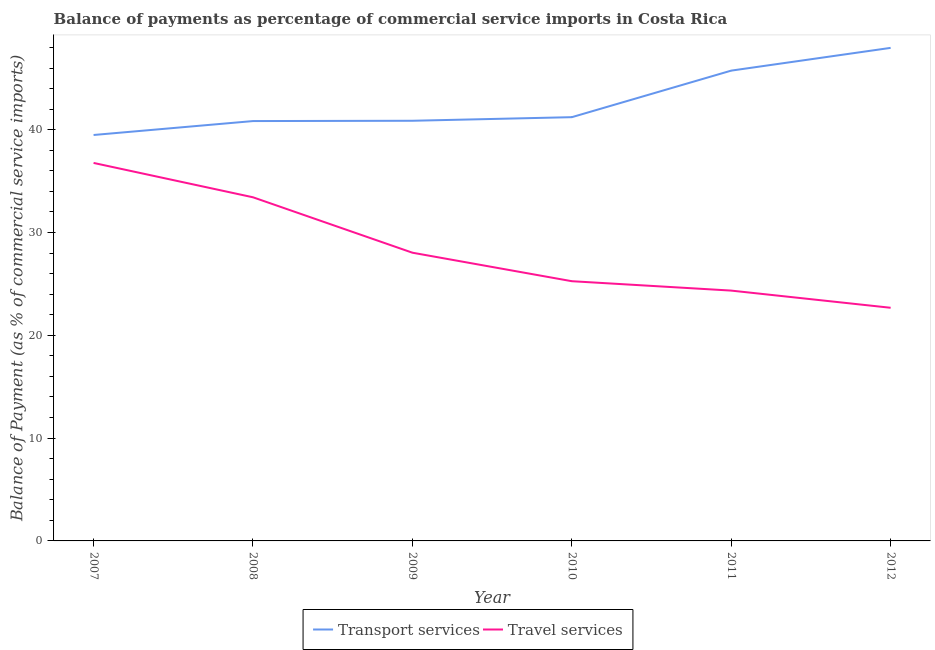How many different coloured lines are there?
Provide a short and direct response. 2. What is the balance of payments of travel services in 2010?
Offer a very short reply. 25.26. Across all years, what is the maximum balance of payments of travel services?
Provide a succinct answer. 36.77. Across all years, what is the minimum balance of payments of transport services?
Your response must be concise. 39.48. In which year was the balance of payments of travel services maximum?
Offer a terse response. 2007. What is the total balance of payments of travel services in the graph?
Your answer should be compact. 170.52. What is the difference between the balance of payments of travel services in 2011 and that in 2012?
Your response must be concise. 1.67. What is the difference between the balance of payments of travel services in 2010 and the balance of payments of transport services in 2007?
Keep it short and to the point. -14.22. What is the average balance of payments of travel services per year?
Your answer should be very brief. 28.42. In the year 2008, what is the difference between the balance of payments of transport services and balance of payments of travel services?
Offer a very short reply. 7.41. In how many years, is the balance of payments of transport services greater than 16 %?
Your answer should be very brief. 6. What is the ratio of the balance of payments of travel services in 2010 to that in 2011?
Your response must be concise. 1.04. Is the balance of payments of transport services in 2008 less than that in 2010?
Your response must be concise. Yes. What is the difference between the highest and the second highest balance of payments of transport services?
Make the answer very short. 2.21. What is the difference between the highest and the lowest balance of payments of travel services?
Offer a terse response. 14.09. Does the balance of payments of travel services monotonically increase over the years?
Ensure brevity in your answer.  No. Is the balance of payments of travel services strictly greater than the balance of payments of transport services over the years?
Provide a succinct answer. No. Is the balance of payments of transport services strictly less than the balance of payments of travel services over the years?
Ensure brevity in your answer.  No. Are the values on the major ticks of Y-axis written in scientific E-notation?
Ensure brevity in your answer.  No. Does the graph contain any zero values?
Your answer should be very brief. No. Where does the legend appear in the graph?
Provide a succinct answer. Bottom center. How are the legend labels stacked?
Make the answer very short. Horizontal. What is the title of the graph?
Make the answer very short. Balance of payments as percentage of commercial service imports in Costa Rica. What is the label or title of the X-axis?
Ensure brevity in your answer.  Year. What is the label or title of the Y-axis?
Provide a short and direct response. Balance of Payment (as % of commercial service imports). What is the Balance of Payment (as % of commercial service imports) of Transport services in 2007?
Keep it short and to the point. 39.48. What is the Balance of Payment (as % of commercial service imports) of Travel services in 2007?
Provide a short and direct response. 36.77. What is the Balance of Payment (as % of commercial service imports) in Transport services in 2008?
Provide a short and direct response. 40.84. What is the Balance of Payment (as % of commercial service imports) in Travel services in 2008?
Your response must be concise. 33.43. What is the Balance of Payment (as % of commercial service imports) of Transport services in 2009?
Your response must be concise. 40.87. What is the Balance of Payment (as % of commercial service imports) of Travel services in 2009?
Your answer should be compact. 28.03. What is the Balance of Payment (as % of commercial service imports) of Transport services in 2010?
Give a very brief answer. 41.22. What is the Balance of Payment (as % of commercial service imports) of Travel services in 2010?
Ensure brevity in your answer.  25.26. What is the Balance of Payment (as % of commercial service imports) in Transport services in 2011?
Make the answer very short. 45.75. What is the Balance of Payment (as % of commercial service imports) of Travel services in 2011?
Provide a succinct answer. 24.35. What is the Balance of Payment (as % of commercial service imports) of Transport services in 2012?
Make the answer very short. 47.96. What is the Balance of Payment (as % of commercial service imports) of Travel services in 2012?
Offer a terse response. 22.68. Across all years, what is the maximum Balance of Payment (as % of commercial service imports) of Transport services?
Provide a succinct answer. 47.96. Across all years, what is the maximum Balance of Payment (as % of commercial service imports) in Travel services?
Give a very brief answer. 36.77. Across all years, what is the minimum Balance of Payment (as % of commercial service imports) of Transport services?
Make the answer very short. 39.48. Across all years, what is the minimum Balance of Payment (as % of commercial service imports) of Travel services?
Provide a succinct answer. 22.68. What is the total Balance of Payment (as % of commercial service imports) in Transport services in the graph?
Make the answer very short. 256.11. What is the total Balance of Payment (as % of commercial service imports) in Travel services in the graph?
Keep it short and to the point. 170.52. What is the difference between the Balance of Payment (as % of commercial service imports) of Transport services in 2007 and that in 2008?
Offer a terse response. -1.35. What is the difference between the Balance of Payment (as % of commercial service imports) of Travel services in 2007 and that in 2008?
Provide a short and direct response. 3.34. What is the difference between the Balance of Payment (as % of commercial service imports) in Transport services in 2007 and that in 2009?
Ensure brevity in your answer.  -1.38. What is the difference between the Balance of Payment (as % of commercial service imports) in Travel services in 2007 and that in 2009?
Your response must be concise. 8.73. What is the difference between the Balance of Payment (as % of commercial service imports) of Transport services in 2007 and that in 2010?
Ensure brevity in your answer.  -1.73. What is the difference between the Balance of Payment (as % of commercial service imports) of Travel services in 2007 and that in 2010?
Make the answer very short. 11.5. What is the difference between the Balance of Payment (as % of commercial service imports) in Transport services in 2007 and that in 2011?
Make the answer very short. -6.26. What is the difference between the Balance of Payment (as % of commercial service imports) in Travel services in 2007 and that in 2011?
Ensure brevity in your answer.  12.42. What is the difference between the Balance of Payment (as % of commercial service imports) in Transport services in 2007 and that in 2012?
Your response must be concise. -8.47. What is the difference between the Balance of Payment (as % of commercial service imports) of Travel services in 2007 and that in 2012?
Offer a terse response. 14.09. What is the difference between the Balance of Payment (as % of commercial service imports) in Transport services in 2008 and that in 2009?
Your response must be concise. -0.03. What is the difference between the Balance of Payment (as % of commercial service imports) in Travel services in 2008 and that in 2009?
Ensure brevity in your answer.  5.39. What is the difference between the Balance of Payment (as % of commercial service imports) of Transport services in 2008 and that in 2010?
Provide a short and direct response. -0.38. What is the difference between the Balance of Payment (as % of commercial service imports) in Travel services in 2008 and that in 2010?
Your answer should be very brief. 8.16. What is the difference between the Balance of Payment (as % of commercial service imports) of Transport services in 2008 and that in 2011?
Your response must be concise. -4.91. What is the difference between the Balance of Payment (as % of commercial service imports) in Travel services in 2008 and that in 2011?
Provide a short and direct response. 9.08. What is the difference between the Balance of Payment (as % of commercial service imports) in Transport services in 2008 and that in 2012?
Keep it short and to the point. -7.12. What is the difference between the Balance of Payment (as % of commercial service imports) of Travel services in 2008 and that in 2012?
Ensure brevity in your answer.  10.75. What is the difference between the Balance of Payment (as % of commercial service imports) of Transport services in 2009 and that in 2010?
Your response must be concise. -0.35. What is the difference between the Balance of Payment (as % of commercial service imports) of Travel services in 2009 and that in 2010?
Provide a succinct answer. 2.77. What is the difference between the Balance of Payment (as % of commercial service imports) of Transport services in 2009 and that in 2011?
Your answer should be compact. -4.88. What is the difference between the Balance of Payment (as % of commercial service imports) of Travel services in 2009 and that in 2011?
Your answer should be compact. 3.69. What is the difference between the Balance of Payment (as % of commercial service imports) of Transport services in 2009 and that in 2012?
Your answer should be very brief. -7.09. What is the difference between the Balance of Payment (as % of commercial service imports) in Travel services in 2009 and that in 2012?
Give a very brief answer. 5.36. What is the difference between the Balance of Payment (as % of commercial service imports) in Transport services in 2010 and that in 2011?
Make the answer very short. -4.53. What is the difference between the Balance of Payment (as % of commercial service imports) of Travel services in 2010 and that in 2011?
Your answer should be very brief. 0.91. What is the difference between the Balance of Payment (as % of commercial service imports) in Transport services in 2010 and that in 2012?
Your response must be concise. -6.74. What is the difference between the Balance of Payment (as % of commercial service imports) in Travel services in 2010 and that in 2012?
Provide a short and direct response. 2.58. What is the difference between the Balance of Payment (as % of commercial service imports) of Transport services in 2011 and that in 2012?
Your response must be concise. -2.21. What is the difference between the Balance of Payment (as % of commercial service imports) of Travel services in 2011 and that in 2012?
Provide a short and direct response. 1.67. What is the difference between the Balance of Payment (as % of commercial service imports) of Transport services in 2007 and the Balance of Payment (as % of commercial service imports) of Travel services in 2008?
Offer a very short reply. 6.06. What is the difference between the Balance of Payment (as % of commercial service imports) of Transport services in 2007 and the Balance of Payment (as % of commercial service imports) of Travel services in 2009?
Provide a succinct answer. 11.45. What is the difference between the Balance of Payment (as % of commercial service imports) in Transport services in 2007 and the Balance of Payment (as % of commercial service imports) in Travel services in 2010?
Your response must be concise. 14.22. What is the difference between the Balance of Payment (as % of commercial service imports) of Transport services in 2007 and the Balance of Payment (as % of commercial service imports) of Travel services in 2011?
Offer a terse response. 15.14. What is the difference between the Balance of Payment (as % of commercial service imports) in Transport services in 2007 and the Balance of Payment (as % of commercial service imports) in Travel services in 2012?
Keep it short and to the point. 16.81. What is the difference between the Balance of Payment (as % of commercial service imports) of Transport services in 2008 and the Balance of Payment (as % of commercial service imports) of Travel services in 2009?
Your answer should be very brief. 12.8. What is the difference between the Balance of Payment (as % of commercial service imports) of Transport services in 2008 and the Balance of Payment (as % of commercial service imports) of Travel services in 2010?
Make the answer very short. 15.58. What is the difference between the Balance of Payment (as % of commercial service imports) of Transport services in 2008 and the Balance of Payment (as % of commercial service imports) of Travel services in 2011?
Provide a short and direct response. 16.49. What is the difference between the Balance of Payment (as % of commercial service imports) of Transport services in 2008 and the Balance of Payment (as % of commercial service imports) of Travel services in 2012?
Offer a terse response. 18.16. What is the difference between the Balance of Payment (as % of commercial service imports) in Transport services in 2009 and the Balance of Payment (as % of commercial service imports) in Travel services in 2010?
Give a very brief answer. 15.61. What is the difference between the Balance of Payment (as % of commercial service imports) of Transport services in 2009 and the Balance of Payment (as % of commercial service imports) of Travel services in 2011?
Provide a short and direct response. 16.52. What is the difference between the Balance of Payment (as % of commercial service imports) in Transport services in 2009 and the Balance of Payment (as % of commercial service imports) in Travel services in 2012?
Ensure brevity in your answer.  18.19. What is the difference between the Balance of Payment (as % of commercial service imports) of Transport services in 2010 and the Balance of Payment (as % of commercial service imports) of Travel services in 2011?
Make the answer very short. 16.87. What is the difference between the Balance of Payment (as % of commercial service imports) of Transport services in 2010 and the Balance of Payment (as % of commercial service imports) of Travel services in 2012?
Provide a short and direct response. 18.54. What is the difference between the Balance of Payment (as % of commercial service imports) of Transport services in 2011 and the Balance of Payment (as % of commercial service imports) of Travel services in 2012?
Provide a short and direct response. 23.07. What is the average Balance of Payment (as % of commercial service imports) of Transport services per year?
Give a very brief answer. 42.69. What is the average Balance of Payment (as % of commercial service imports) in Travel services per year?
Provide a short and direct response. 28.42. In the year 2007, what is the difference between the Balance of Payment (as % of commercial service imports) of Transport services and Balance of Payment (as % of commercial service imports) of Travel services?
Your answer should be compact. 2.72. In the year 2008, what is the difference between the Balance of Payment (as % of commercial service imports) of Transport services and Balance of Payment (as % of commercial service imports) of Travel services?
Your answer should be compact. 7.41. In the year 2009, what is the difference between the Balance of Payment (as % of commercial service imports) of Transport services and Balance of Payment (as % of commercial service imports) of Travel services?
Give a very brief answer. 12.83. In the year 2010, what is the difference between the Balance of Payment (as % of commercial service imports) in Transport services and Balance of Payment (as % of commercial service imports) in Travel services?
Provide a succinct answer. 15.95. In the year 2011, what is the difference between the Balance of Payment (as % of commercial service imports) in Transport services and Balance of Payment (as % of commercial service imports) in Travel services?
Your answer should be very brief. 21.4. In the year 2012, what is the difference between the Balance of Payment (as % of commercial service imports) of Transport services and Balance of Payment (as % of commercial service imports) of Travel services?
Make the answer very short. 25.28. What is the ratio of the Balance of Payment (as % of commercial service imports) of Transport services in 2007 to that in 2008?
Give a very brief answer. 0.97. What is the ratio of the Balance of Payment (as % of commercial service imports) of Travel services in 2007 to that in 2008?
Your answer should be compact. 1.1. What is the ratio of the Balance of Payment (as % of commercial service imports) in Transport services in 2007 to that in 2009?
Make the answer very short. 0.97. What is the ratio of the Balance of Payment (as % of commercial service imports) in Travel services in 2007 to that in 2009?
Your answer should be compact. 1.31. What is the ratio of the Balance of Payment (as % of commercial service imports) in Transport services in 2007 to that in 2010?
Provide a succinct answer. 0.96. What is the ratio of the Balance of Payment (as % of commercial service imports) in Travel services in 2007 to that in 2010?
Offer a terse response. 1.46. What is the ratio of the Balance of Payment (as % of commercial service imports) in Transport services in 2007 to that in 2011?
Offer a very short reply. 0.86. What is the ratio of the Balance of Payment (as % of commercial service imports) in Travel services in 2007 to that in 2011?
Offer a terse response. 1.51. What is the ratio of the Balance of Payment (as % of commercial service imports) of Transport services in 2007 to that in 2012?
Your answer should be very brief. 0.82. What is the ratio of the Balance of Payment (as % of commercial service imports) of Travel services in 2007 to that in 2012?
Your answer should be compact. 1.62. What is the ratio of the Balance of Payment (as % of commercial service imports) in Transport services in 2008 to that in 2009?
Provide a succinct answer. 1. What is the ratio of the Balance of Payment (as % of commercial service imports) of Travel services in 2008 to that in 2009?
Ensure brevity in your answer.  1.19. What is the ratio of the Balance of Payment (as % of commercial service imports) of Travel services in 2008 to that in 2010?
Keep it short and to the point. 1.32. What is the ratio of the Balance of Payment (as % of commercial service imports) in Transport services in 2008 to that in 2011?
Make the answer very short. 0.89. What is the ratio of the Balance of Payment (as % of commercial service imports) of Travel services in 2008 to that in 2011?
Your answer should be very brief. 1.37. What is the ratio of the Balance of Payment (as % of commercial service imports) in Transport services in 2008 to that in 2012?
Ensure brevity in your answer.  0.85. What is the ratio of the Balance of Payment (as % of commercial service imports) in Travel services in 2008 to that in 2012?
Your answer should be compact. 1.47. What is the ratio of the Balance of Payment (as % of commercial service imports) of Travel services in 2009 to that in 2010?
Provide a short and direct response. 1.11. What is the ratio of the Balance of Payment (as % of commercial service imports) in Transport services in 2009 to that in 2011?
Offer a very short reply. 0.89. What is the ratio of the Balance of Payment (as % of commercial service imports) in Travel services in 2009 to that in 2011?
Ensure brevity in your answer.  1.15. What is the ratio of the Balance of Payment (as % of commercial service imports) of Transport services in 2009 to that in 2012?
Offer a terse response. 0.85. What is the ratio of the Balance of Payment (as % of commercial service imports) of Travel services in 2009 to that in 2012?
Offer a terse response. 1.24. What is the ratio of the Balance of Payment (as % of commercial service imports) of Transport services in 2010 to that in 2011?
Your response must be concise. 0.9. What is the ratio of the Balance of Payment (as % of commercial service imports) of Travel services in 2010 to that in 2011?
Your answer should be compact. 1.04. What is the ratio of the Balance of Payment (as % of commercial service imports) in Transport services in 2010 to that in 2012?
Your response must be concise. 0.86. What is the ratio of the Balance of Payment (as % of commercial service imports) of Travel services in 2010 to that in 2012?
Keep it short and to the point. 1.11. What is the ratio of the Balance of Payment (as % of commercial service imports) in Transport services in 2011 to that in 2012?
Offer a terse response. 0.95. What is the ratio of the Balance of Payment (as % of commercial service imports) in Travel services in 2011 to that in 2012?
Give a very brief answer. 1.07. What is the difference between the highest and the second highest Balance of Payment (as % of commercial service imports) of Transport services?
Give a very brief answer. 2.21. What is the difference between the highest and the second highest Balance of Payment (as % of commercial service imports) of Travel services?
Keep it short and to the point. 3.34. What is the difference between the highest and the lowest Balance of Payment (as % of commercial service imports) of Transport services?
Give a very brief answer. 8.47. What is the difference between the highest and the lowest Balance of Payment (as % of commercial service imports) of Travel services?
Your answer should be very brief. 14.09. 